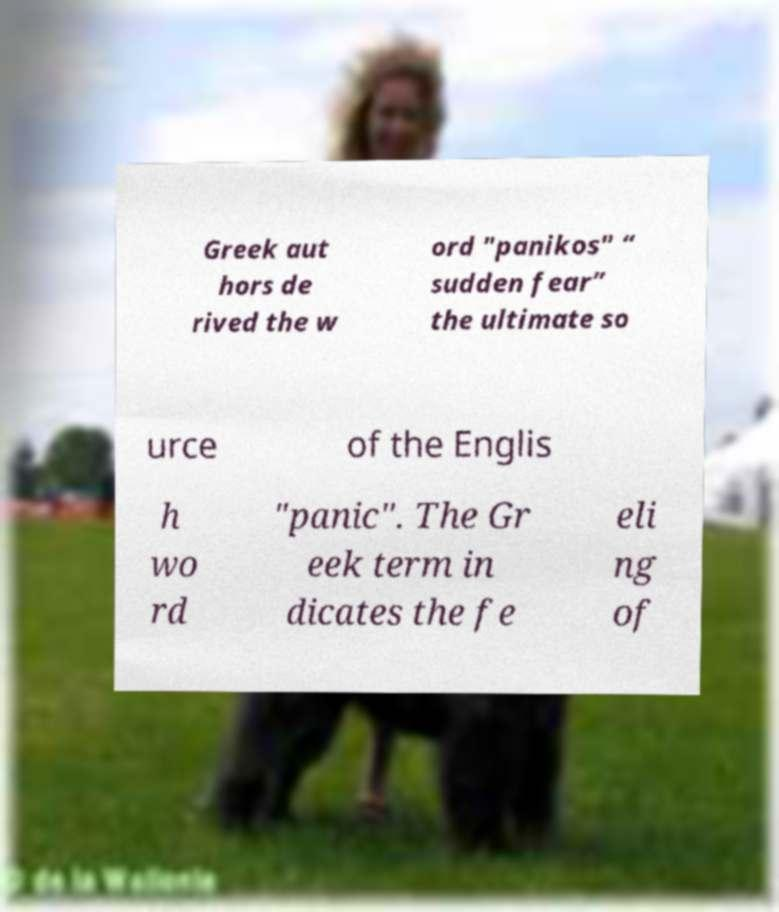Please read and relay the text visible in this image. What does it say? Greek aut hors de rived the w ord "panikos" “ sudden fear” the ultimate so urce of the Englis h wo rd "panic". The Gr eek term in dicates the fe eli ng of 